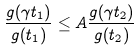Convert formula to latex. <formula><loc_0><loc_0><loc_500><loc_500>\frac { g ( \gamma t _ { 1 } ) } { g ( t _ { 1 } ) } \leq A \frac { g ( \gamma t _ { 2 } ) } { g ( t _ { 2 } ) }</formula> 